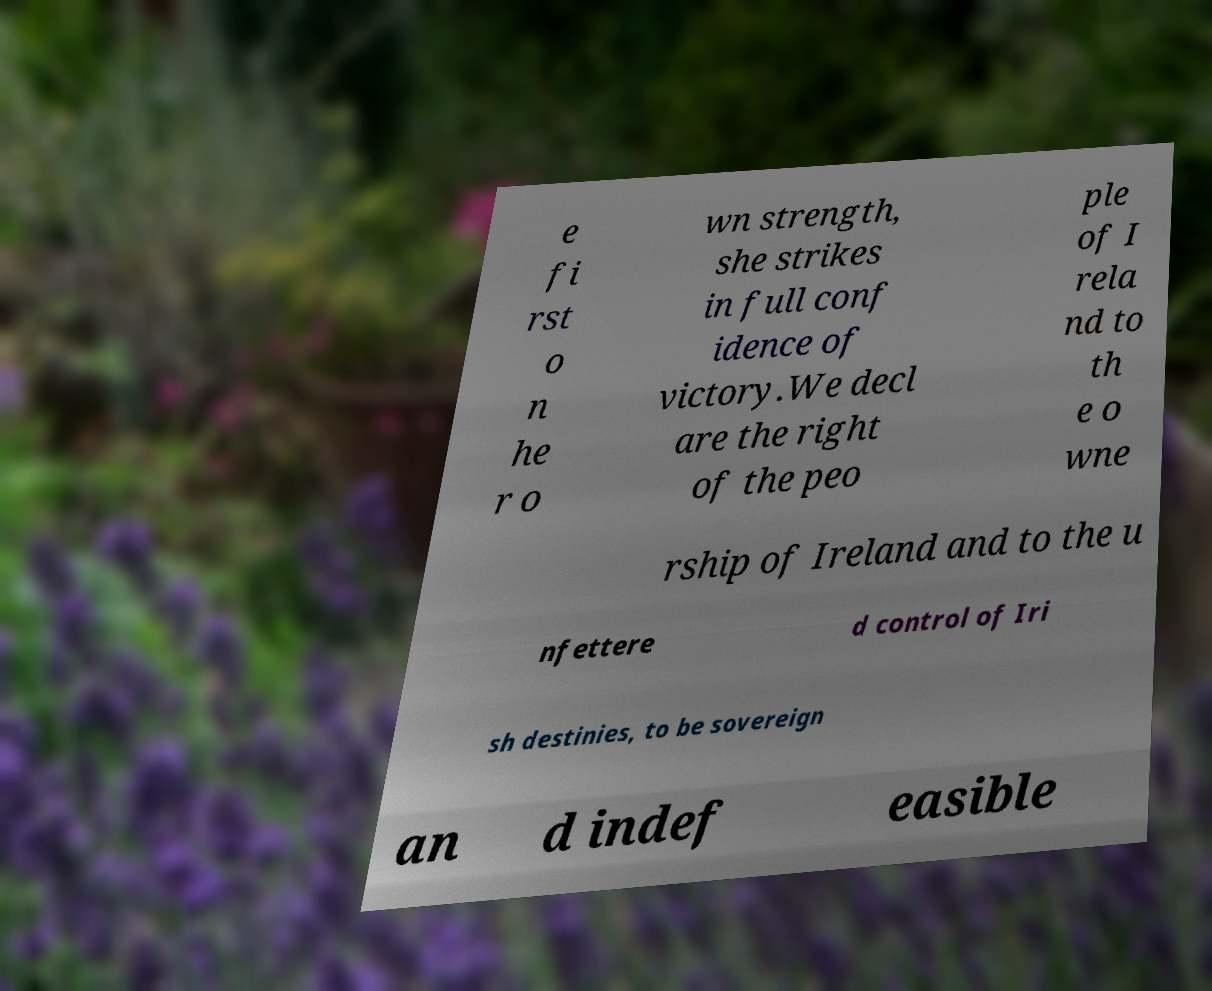Please identify and transcribe the text found in this image. e fi rst o n he r o wn strength, she strikes in full conf idence of victory.We decl are the right of the peo ple of I rela nd to th e o wne rship of Ireland and to the u nfettere d control of Iri sh destinies, to be sovereign an d indef easible 